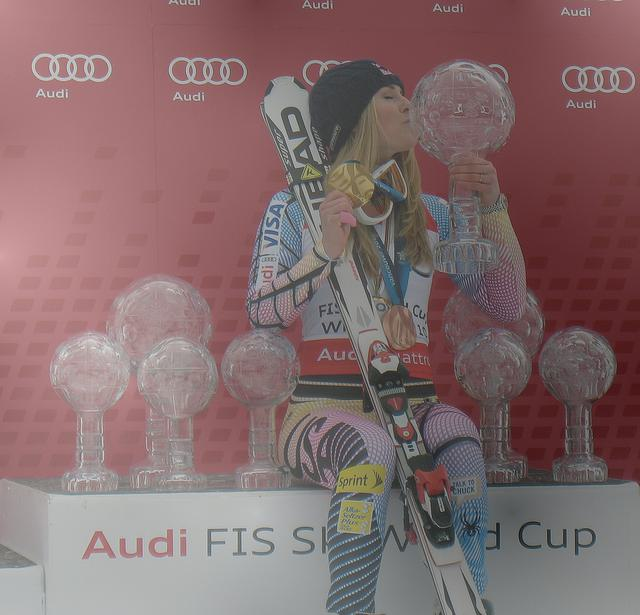What can you infer about the event from the logos and setup in the image? Based on the familiar Audi logo and the official FIS (Fédération Internationale de Ski) branding, it can be inferred that this event is part of the international competitive skiing circuit, possibly a high-profile competition like the FIS Ski World Cup. 